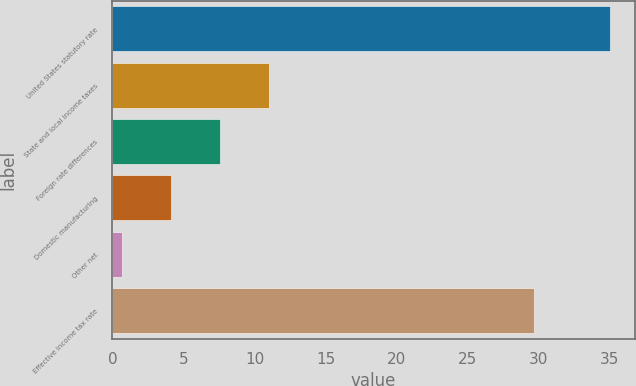Convert chart. <chart><loc_0><loc_0><loc_500><loc_500><bar_chart><fcel>United States statutory rate<fcel>State and local income taxes<fcel>Foreign rate differences<fcel>Domestic manufacturing<fcel>Other net<fcel>Effective income tax rate<nl><fcel>35<fcel>10.99<fcel>7.56<fcel>4.13<fcel>0.7<fcel>29.7<nl></chart> 